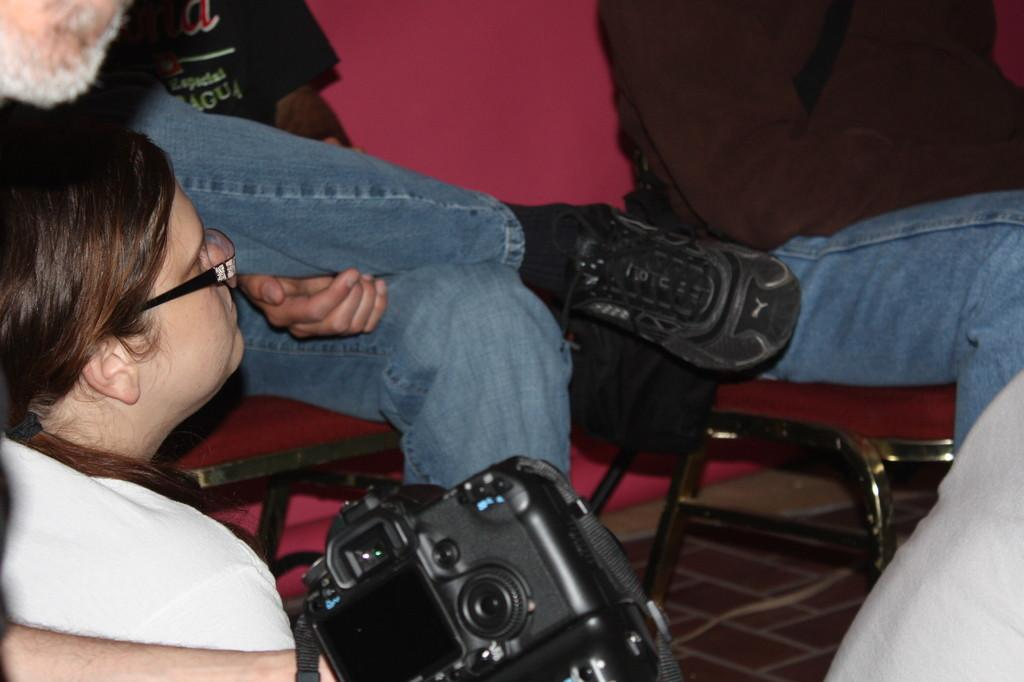What are the people in the image doing? The people in the image are sitting in the center of the image. What are the people sitting on? The people are sitting on chairs. Can you describe the object someone is holding at the bottom side of the image? There is a camera in someone's hand at the bottom side of the image. What type of coast can be seen in the middle of the image? There is no coast present in the image; it features people sitting on chairs. What organization is responsible for the gathering of people in the image? There is no indication of an organization responsible for the gathering of people in the image. 